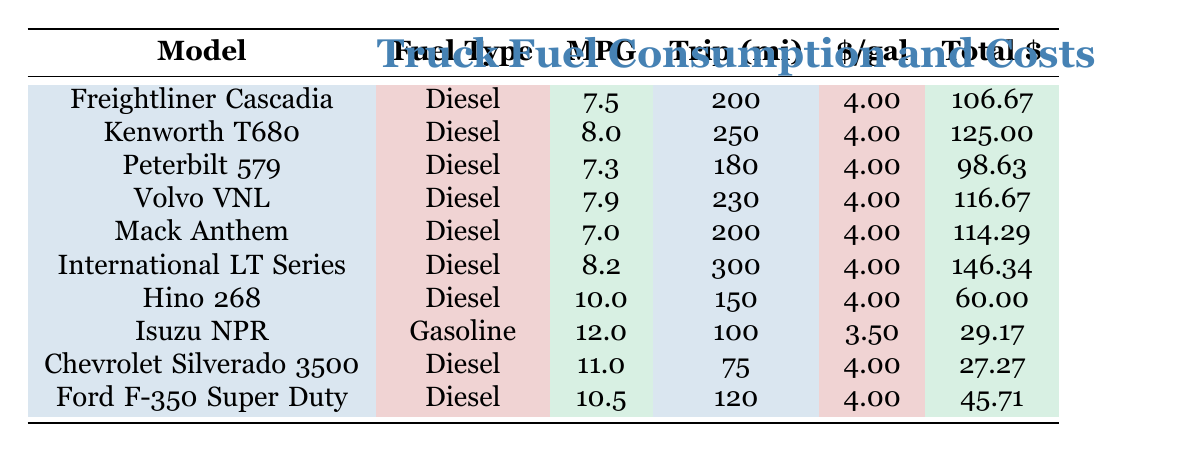What is the average MPG of the trucks listed? To find the average MPG, I sum the MPG values for all trucks: (7.5 + 8.0 + 7.3 + 7.9 + 7.0 + 8.2 + 10.0 + 12.0 + 11.0 + 10.5) = 79.4. There are 10 trucks, so I divide 79.4 by 10 to get 7.94 MPG.
Answer: 7.94 Which truck has the highest total fuel cost? Scanning the total fuel costs, the International LT Series has the highest cost of 146.34.
Answer: International LT Series Is the average fuel consumption of the Chevrolet Silverado 3500 greater than 10 MPG? The Chevrolet Silverado 3500 has an average fuel consumption of 11.0 MPG, which is greater than 10 MPG.
Answer: Yes How much more does it cost to fuel the International LT Series compared to the Hino 268? The total fuel cost for the International LT Series is 146.34 and for the Hino 268 is 60.00, so I calculate the difference: 146.34 - 60.00 = 86.34.
Answer: 86.34 Which truck type has the lowest average fuel consumption? Comparing the average MPG of all trucks, the Mack Anthem has the lowest at 7.0 MPG.
Answer: Mack Anthem Is the fuel type for all trucks either Diesel or Gasoline? Checking the fuel types listed, they are all either Diesel or Gasoline.
Answer: Yes What is the total fuel cost for the trucks that have a trip length of more than 200 miles? The trucks with trip lengths over 200 miles are Kenworth T680 (125.00), Volvo VNL (116.67), International LT Series (146.34), and Freightliner Cascadia (106.67), so I sum these costs: 125.00 + 116.67 + 146.34 + 106.67 = 494.68.
Answer: 494.68 Which truck has the best average fuel consumption (highest MPG) and what is that MPG? Looking through the MPG values, the Hino 268 has the highest MPG at 10.0.
Answer: Hino 268, 10.0 How much does it cost to fuel the Ford F-350 Super Duty for a trip of 120 miles? The fuel cost for the Ford F-350 Super Duty is given directly in the table as 45.71.
Answer: 45.71 